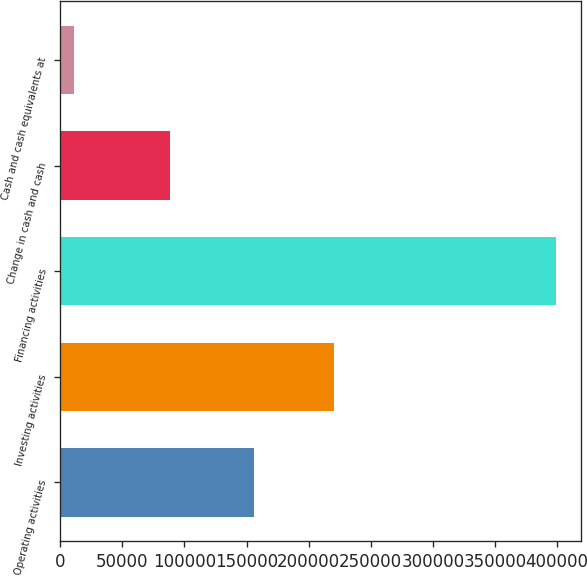Convert chart to OTSL. <chart><loc_0><loc_0><loc_500><loc_500><bar_chart><fcel>Operating activities<fcel>Investing activities<fcel>Financing activities<fcel>Change in cash and cash<fcel>Cash and cash equivalents at<nl><fcel>155893<fcel>220094<fcel>399404<fcel>88504<fcel>10779<nl></chart> 